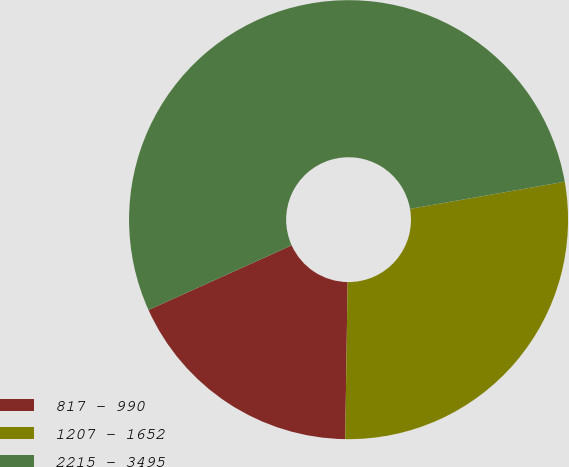Convert chart to OTSL. <chart><loc_0><loc_0><loc_500><loc_500><pie_chart><fcel>817 - 990<fcel>1207 - 1652<fcel>2215 - 3495<nl><fcel>18.01%<fcel>28.01%<fcel>53.98%<nl></chart> 